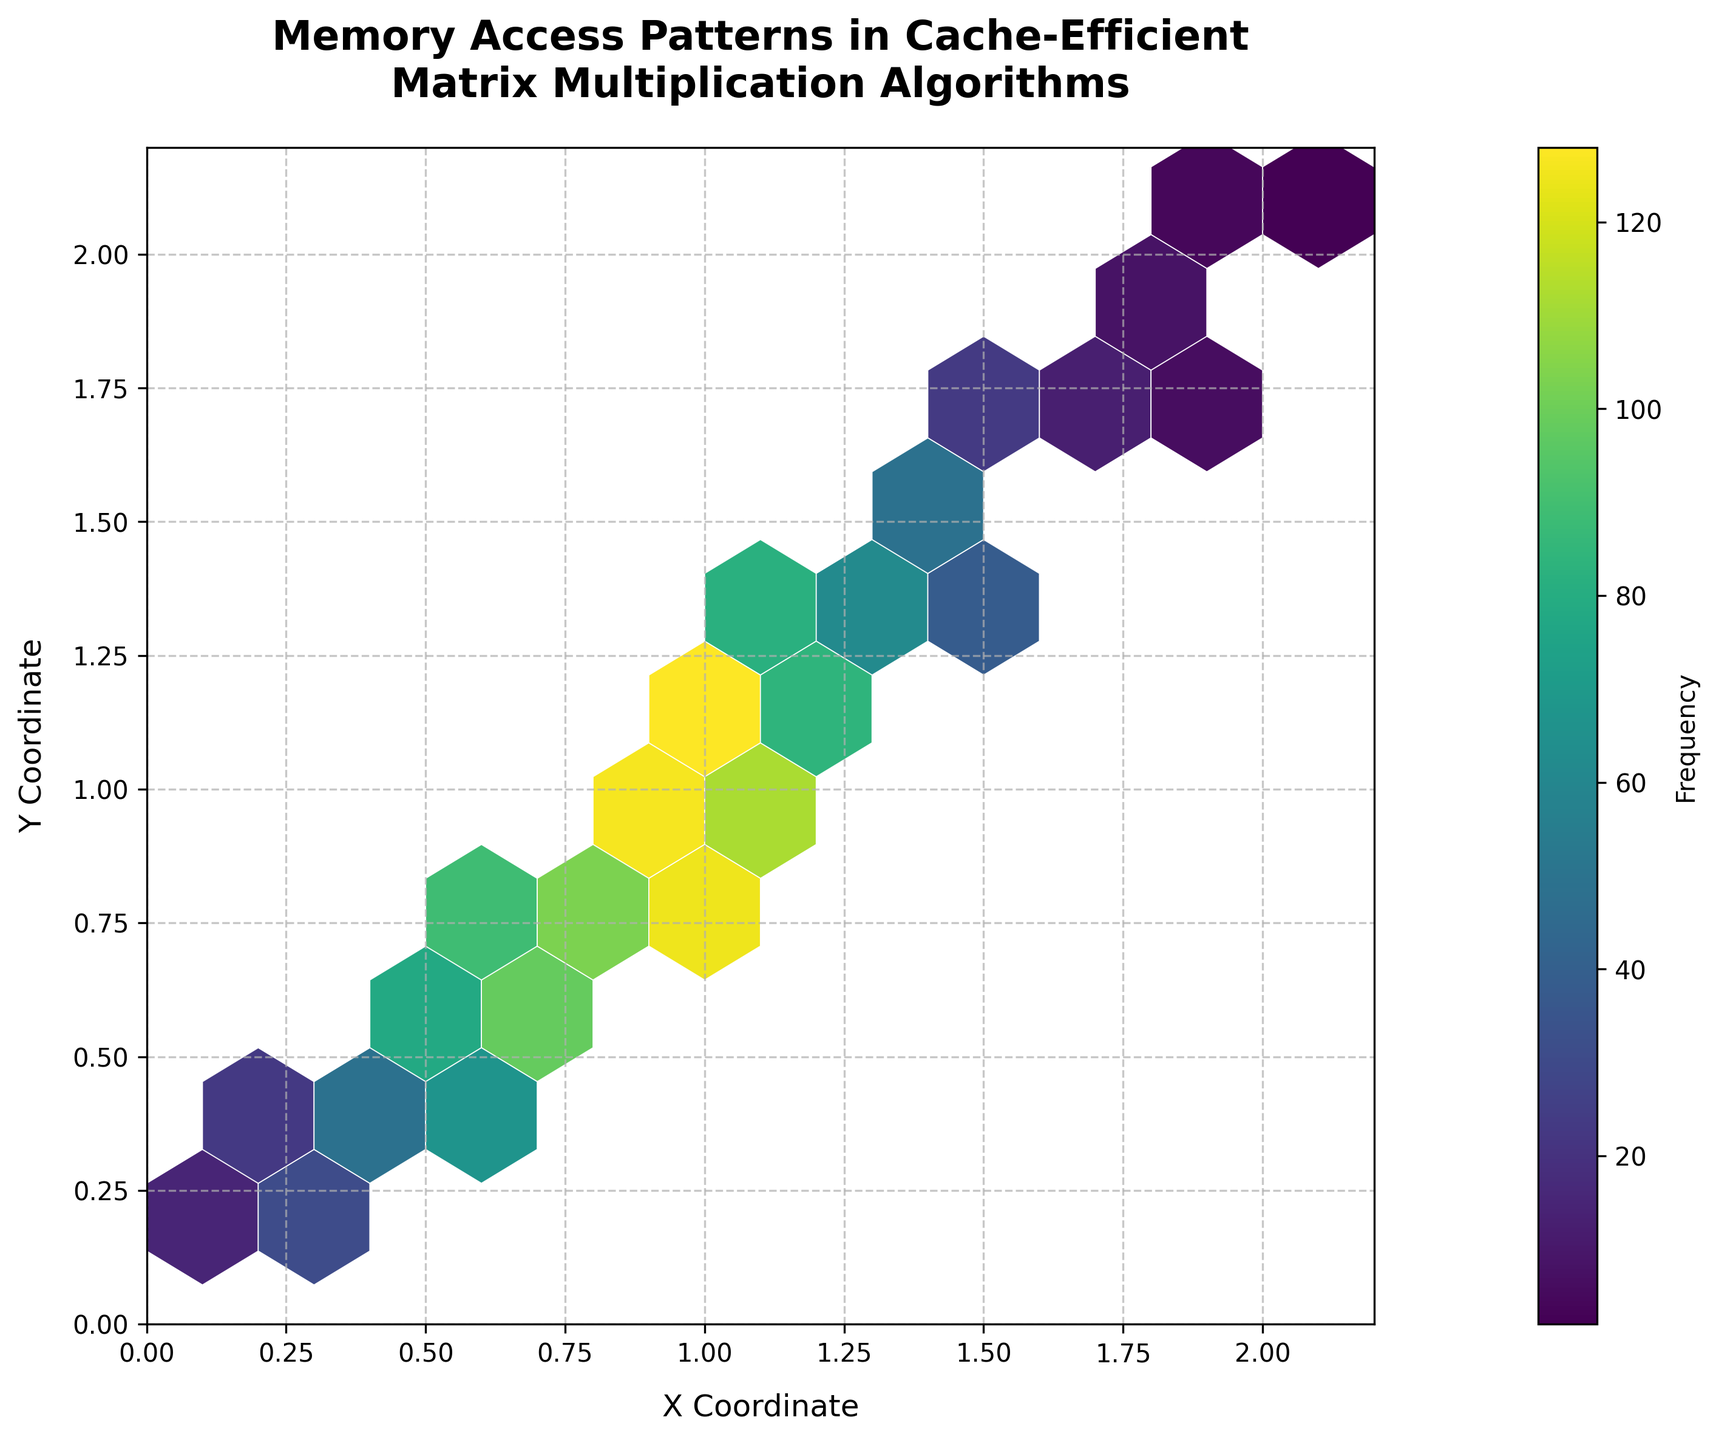What is the title of the hexbin plot? The title is designed to provide an overview of the plot's subject matter. In this case, it is "Memory Access Patterns in Cache-Efficient Matrix Multiplication Algorithms," positioned at the top of the plot.
Answer: Memory Access Patterns in Cache-Efficient Matrix Multiplication Algorithms What are the x and y-axis labels? The x and y-axis labels describe what each axis represents. For the hexbin plot, the x-axis is labeled "X Coordinate," and the y-axis is labeled "Y Coordinate."
Answer: X Coordinate, Y Coordinate How many bins display the highest frequency, and what is their color? The color of the hexbin represents the frequency value, with darker colors indicating higher frequencies according to the 'viridis' color map. The bin with the highest frequency will be the darkest or most saturated color.
Answer: 1 bin, darkest color Is there a noticeable trend in the plot regarding memory access patterns? By observing the distribution and density of the hexagons' colors, we can identify trends. Darker hexagons appear in the bottom right quadrant, indicating higher frequencies in that area.
Answer: Yes, higher frequencies in the bottom right quadrant Which coordinate range (0-1, 1-2, or 2-2.2) shows the highest frequency of memory accesses? By comparing the intensity of hexagon colors in those coordinate ranges, we notice that the range (0-1) shows darker colors, indicating higher frequencies.
Answer: 0-1 What is the approximate frequency value at x=0.5, y=0.6? Find the hexagon located at or near x=0.5, y=0.6, and refer to its color and the color bar to determine the approximate frequency.
Answer: Approximately 78 How does the frequency change as x and y coordinates increase? By examining the overall color gradient, we observe that the frequency reduces, indicated by lighter colors as both x and y coordinates increase.
Answer: Frequency decreases Which data points appear to lie on the main diagonal (where x=y) and have a high frequency? Observe the hexagons that lie roughly on the line where x equals y and check their colors, referring to the color bar for frequency levels.
Answer: x=0.7, y=0.8; x=0.9, y=1.0 What is the color map used in the hexbin plot, and what does it represent? The 'viridis' color map is used, which represents frequencies with a gradation from low (light colors) to high (dark colors).
Answer: viridis, represents frequencies Compare the frequencies at (x=1.0, y=1.1) and (x=1.5, y=1.6). Which one is higher and by how much? Identify the hexagons representing these coordinates, refer to the color bar for their frequencies, and then calculate the difference. x=1.0, y=1.1 has an approximate frequency of 128, and x=1.5, y=1.6 has approximately 28.
Answer: (x=1.0, y=1.1) is higher by about 100 